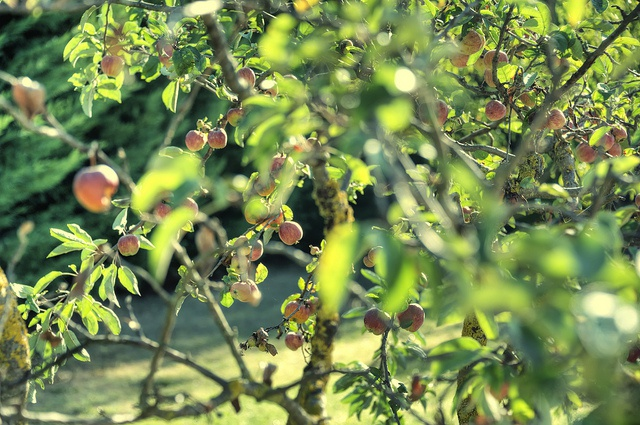Describe the objects in this image and their specific colors. I can see apple in lightgreen, olive, and gray tones, apple in lightgreen, brown, salmon, orange, and khaki tones, apple in lightgreen, tan, gray, and lightyellow tones, apple in lightgreen, gray, maroon, and olive tones, and apple in lightgreen and olive tones in this image. 